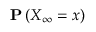Convert formula to latex. <formula><loc_0><loc_0><loc_500><loc_500>{ P } \left ( X _ { \infty } = x \right )</formula> 